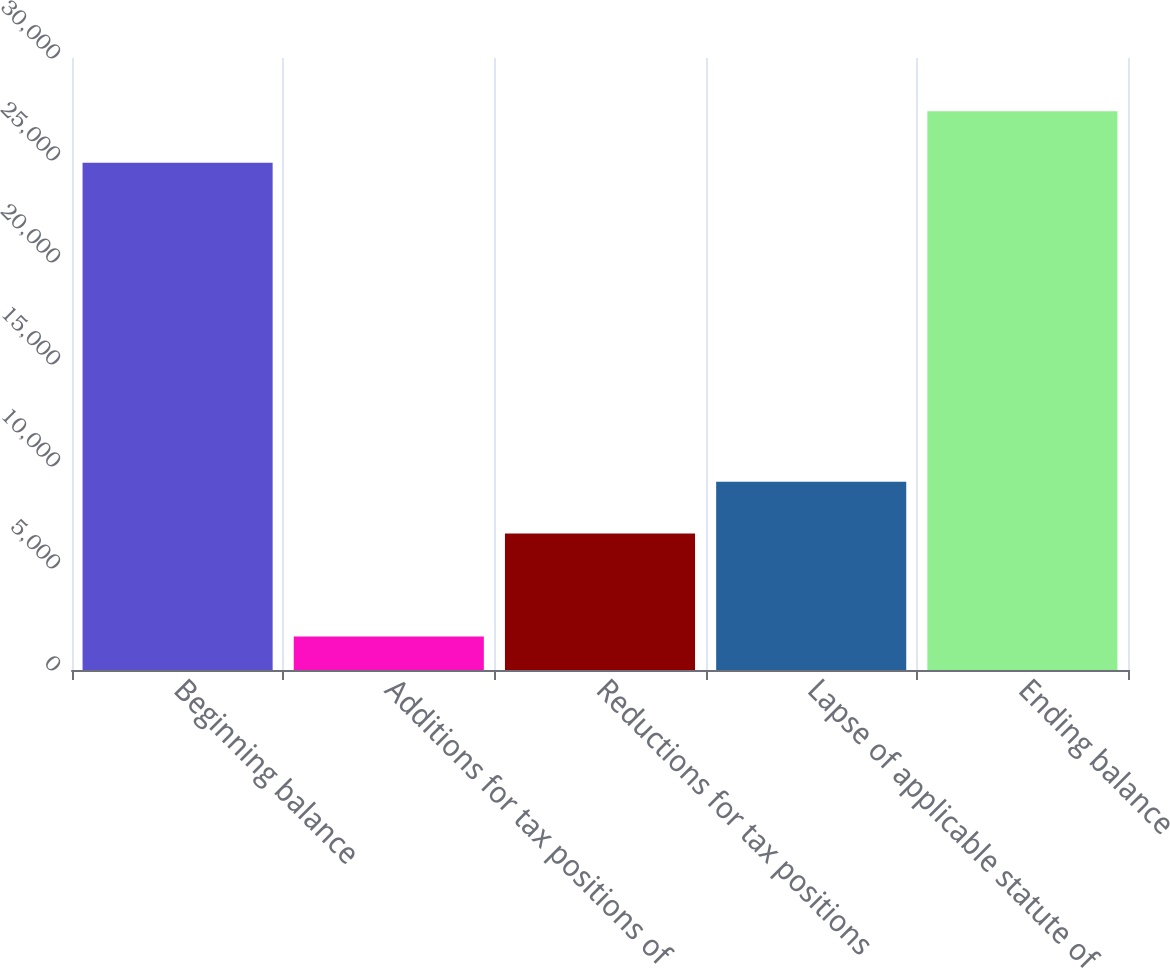Convert chart. <chart><loc_0><loc_0><loc_500><loc_500><bar_chart><fcel>Beginning balance<fcel>Additions for tax positions of<fcel>Reductions for tax positions<fcel>Lapse of applicable statute of<fcel>Ending balance<nl><fcel>24865<fcel>1639<fcel>6696<fcel>9224.5<fcel>27393.5<nl></chart> 